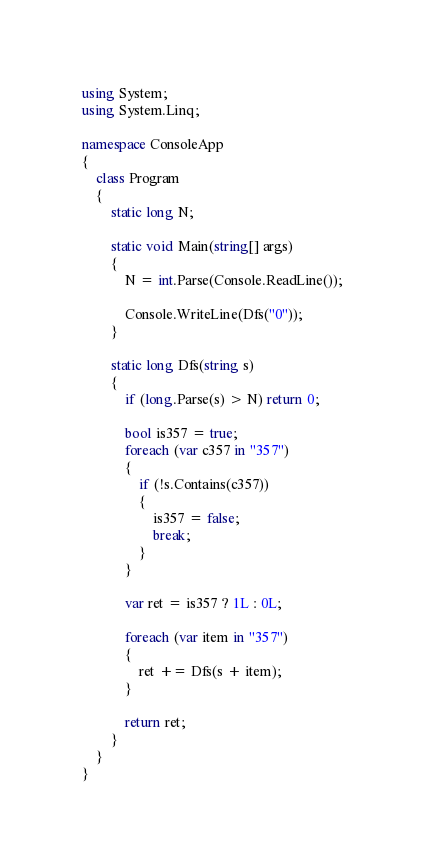Convert code to text. <code><loc_0><loc_0><loc_500><loc_500><_C#_>using System;
using System.Linq;

namespace ConsoleApp
{
    class Program
    {
        static long N;

        static void Main(string[] args)
        {
            N = int.Parse(Console.ReadLine());

            Console.WriteLine(Dfs("0"));
        }

        static long Dfs(string s)
        {
            if (long.Parse(s) > N) return 0;

            bool is357 = true;
            foreach (var c357 in "357")
            {
                if (!s.Contains(c357))
                {
                    is357 = false;
                    break;
                }
            }

            var ret = is357 ? 1L : 0L;

            foreach (var item in "357")
            {
                ret += Dfs(s + item);
            }

            return ret;
        }
    }
}
</code> 